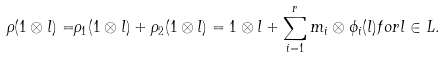Convert formula to latex. <formula><loc_0><loc_0><loc_500><loc_500>\rho ( 1 \otimes l ) = & \rho _ { 1 } ( 1 \otimes l ) + \rho _ { 2 } ( 1 \otimes l ) = 1 \otimes l + \sum _ { i = 1 } ^ { r } m _ { i } \otimes \phi _ { i } ( l ) f o r l \in L .</formula> 